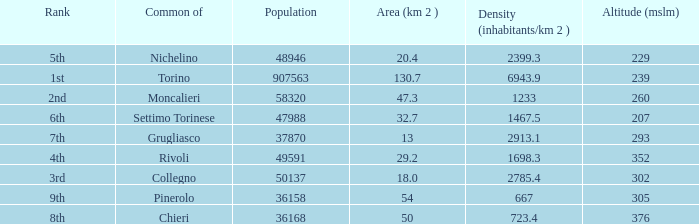What is the density of the common with an area of 20.4 km^2? 2399.3. 